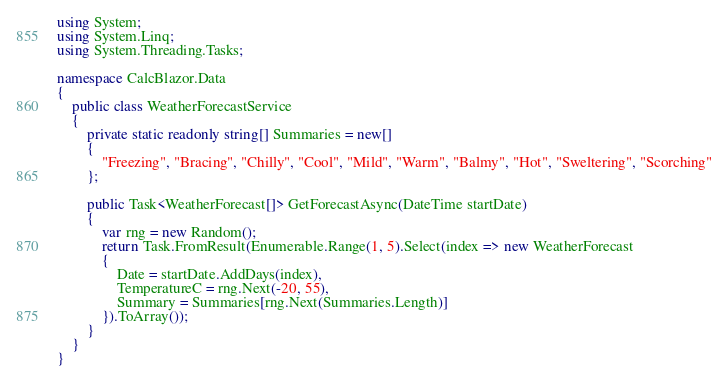Convert code to text. <code><loc_0><loc_0><loc_500><loc_500><_C#_>using System;
using System.Linq;
using System.Threading.Tasks;

namespace CalcBlazor.Data
{
    public class WeatherForecastService
    {
        private static readonly string[] Summaries = new[]
        {
            "Freezing", "Bracing", "Chilly", "Cool", "Mild", "Warm", "Balmy", "Hot", "Sweltering", "Scorching"
        };

        public Task<WeatherForecast[]> GetForecastAsync(DateTime startDate)
        {
            var rng = new Random();
            return Task.FromResult(Enumerable.Range(1, 5).Select(index => new WeatherForecast
            {
                Date = startDate.AddDays(index),
                TemperatureC = rng.Next(-20, 55),
                Summary = Summaries[rng.Next(Summaries.Length)]
            }).ToArray());
        }
    }
}
</code> 